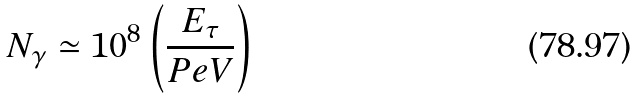<formula> <loc_0><loc_0><loc_500><loc_500>N _ { \gamma } \simeq 1 0 ^ { 8 } \left ( \frac { E _ { \tau } } { P e V } \right )</formula> 